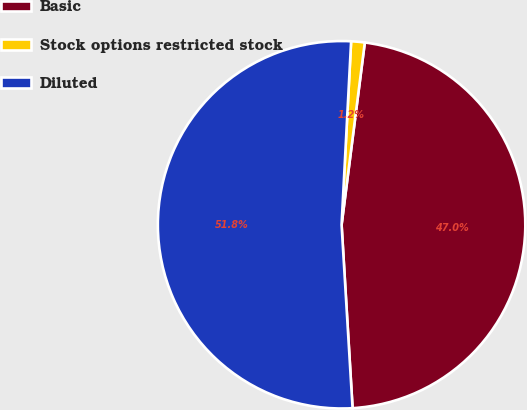<chart> <loc_0><loc_0><loc_500><loc_500><pie_chart><fcel>Basic<fcel>Stock options restricted stock<fcel>Diluted<nl><fcel>47.03%<fcel>1.19%<fcel>51.78%<nl></chart> 